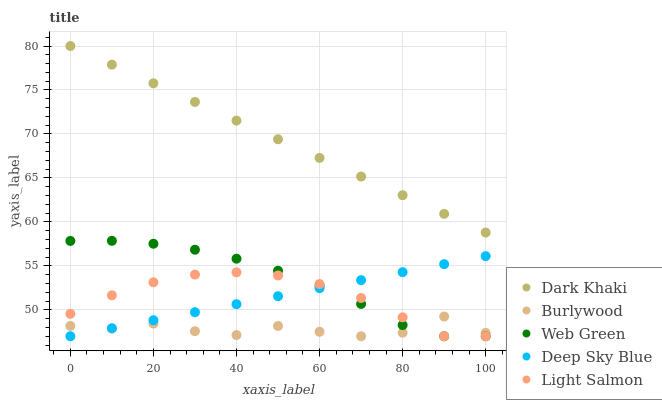Does Burlywood have the minimum area under the curve?
Answer yes or no. Yes. Does Dark Khaki have the maximum area under the curve?
Answer yes or no. Yes. Does Light Salmon have the minimum area under the curve?
Answer yes or no. No. Does Light Salmon have the maximum area under the curve?
Answer yes or no. No. Is Deep Sky Blue the smoothest?
Answer yes or no. Yes. Is Burlywood the roughest?
Answer yes or no. Yes. Is Light Salmon the smoothest?
Answer yes or no. No. Is Light Salmon the roughest?
Answer yes or no. No. Does Burlywood have the lowest value?
Answer yes or no. Yes. Does Dark Khaki have the highest value?
Answer yes or no. Yes. Does Light Salmon have the highest value?
Answer yes or no. No. Is Burlywood less than Dark Khaki?
Answer yes or no. Yes. Is Dark Khaki greater than Light Salmon?
Answer yes or no. Yes. Does Light Salmon intersect Web Green?
Answer yes or no. Yes. Is Light Salmon less than Web Green?
Answer yes or no. No. Is Light Salmon greater than Web Green?
Answer yes or no. No. Does Burlywood intersect Dark Khaki?
Answer yes or no. No. 